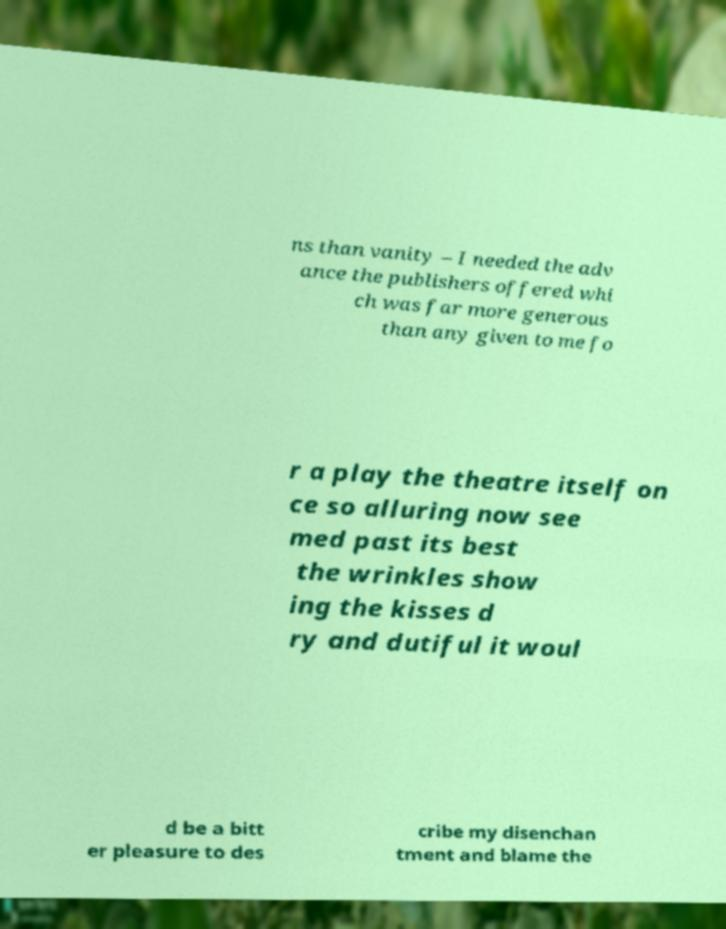For documentation purposes, I need the text within this image transcribed. Could you provide that? ns than vanity – I needed the adv ance the publishers offered whi ch was far more generous than any given to me fo r a play the theatre itself on ce so alluring now see med past its best the wrinkles show ing the kisses d ry and dutiful it woul d be a bitt er pleasure to des cribe my disenchan tment and blame the 